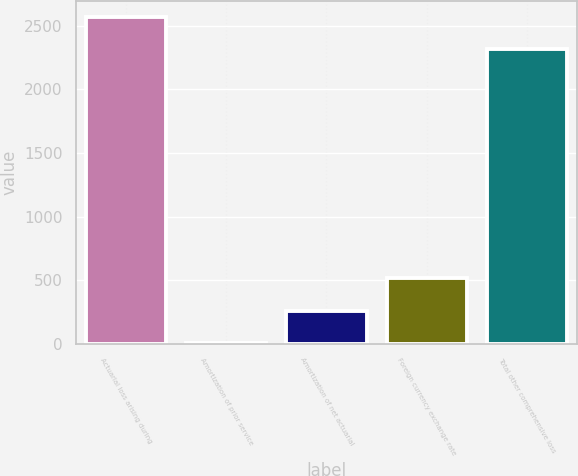<chart> <loc_0><loc_0><loc_500><loc_500><bar_chart><fcel>Actuarial loss arising during<fcel>Amortization of prior service<fcel>Amortization of net actuarial<fcel>Foreign currency exchange rate<fcel>Total other comprehensive loss<nl><fcel>2568.32<fcel>8.2<fcel>260.72<fcel>513.24<fcel>2315.8<nl></chart> 